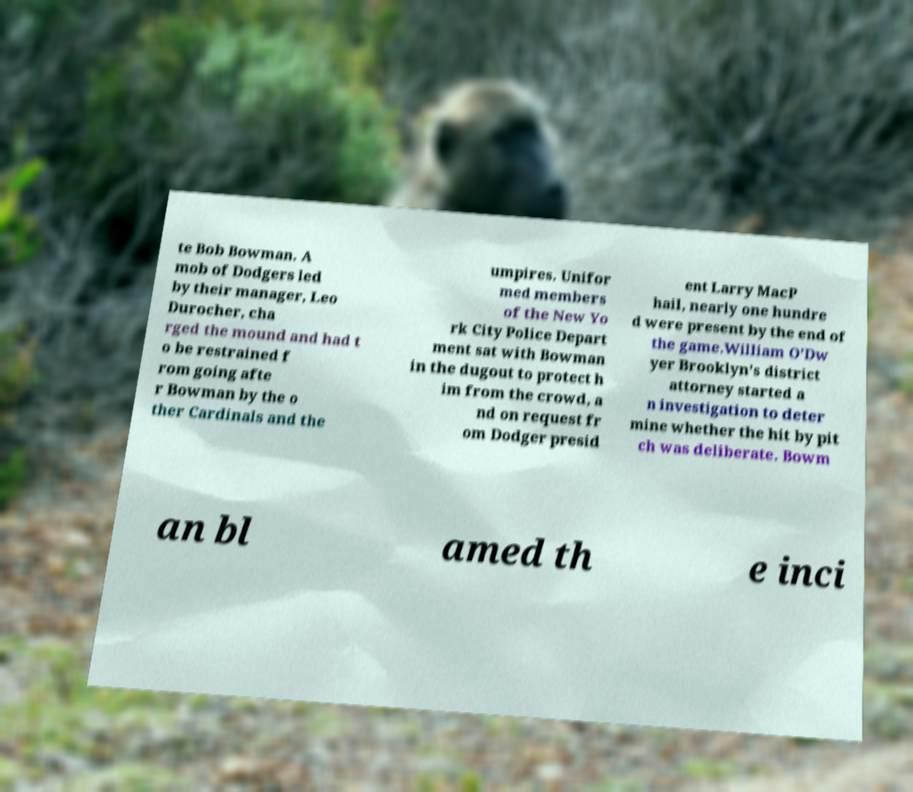Can you accurately transcribe the text from the provided image for me? te Bob Bowman. A mob of Dodgers led by their manager, Leo Durocher, cha rged the mound and had t o be restrained f rom going afte r Bowman by the o ther Cardinals and the umpires. Unifor med members of the New Yo rk City Police Depart ment sat with Bowman in the dugout to protect h im from the crowd, a nd on request fr om Dodger presid ent Larry MacP hail, nearly one hundre d were present by the end of the game.William O'Dw yer Brooklyn's district attorney started a n investigation to deter mine whether the hit by pit ch was deliberate. Bowm an bl amed th e inci 